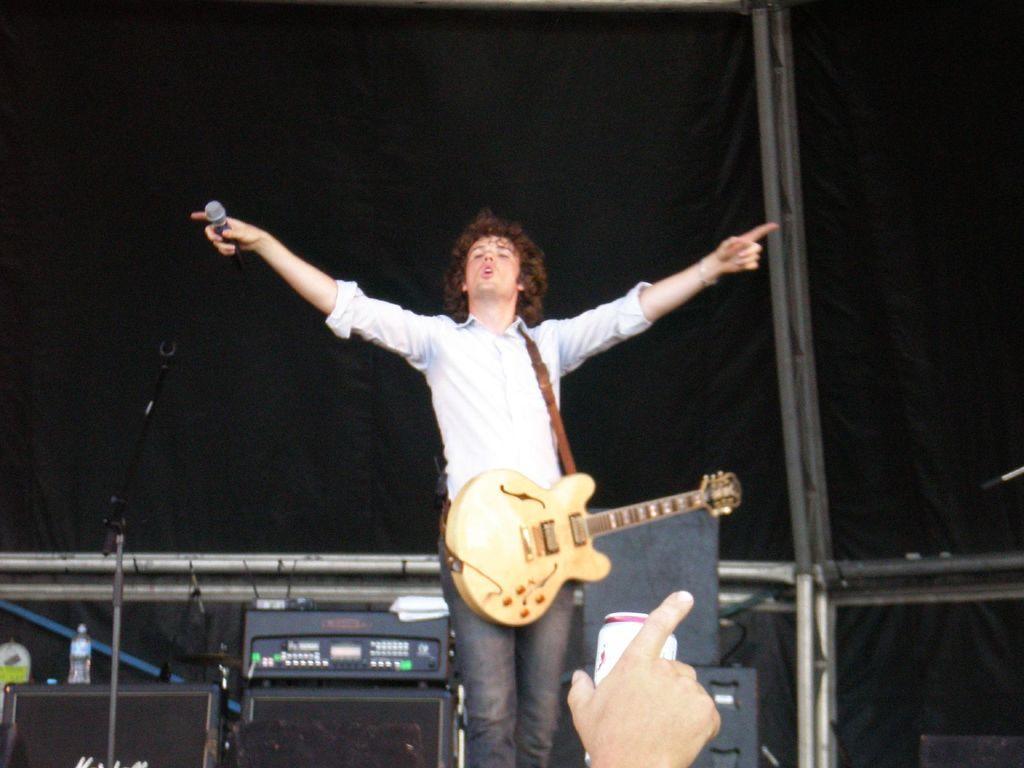Could you give a brief overview of what you see in this image? In this image i can see a person wearing a guitar and holding a mike and his mouth was open and a person hand pointing to some object is visible and left side there is a mike and there is a table on the table there is a bottle and there is a musical instrument 